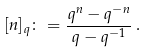Convert formula to latex. <formula><loc_0><loc_0><loc_500><loc_500>[ n ] _ { q } \colon = \frac { q ^ { n } - q ^ { - n } } { q - q ^ { - 1 } } \, .</formula> 